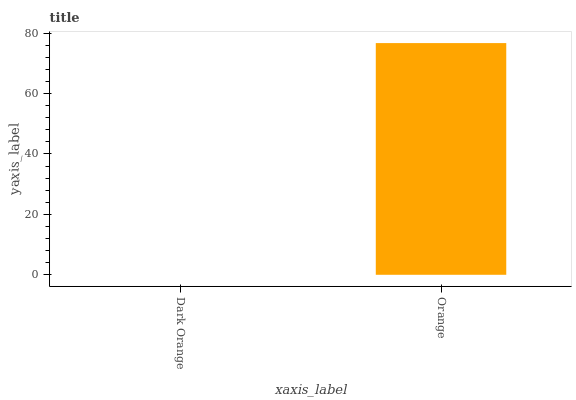Is Dark Orange the minimum?
Answer yes or no. Yes. Is Orange the maximum?
Answer yes or no. Yes. Is Orange the minimum?
Answer yes or no. No. Is Orange greater than Dark Orange?
Answer yes or no. Yes. Is Dark Orange less than Orange?
Answer yes or no. Yes. Is Dark Orange greater than Orange?
Answer yes or no. No. Is Orange less than Dark Orange?
Answer yes or no. No. Is Orange the high median?
Answer yes or no. Yes. Is Dark Orange the low median?
Answer yes or no. Yes. Is Dark Orange the high median?
Answer yes or no. No. Is Orange the low median?
Answer yes or no. No. 